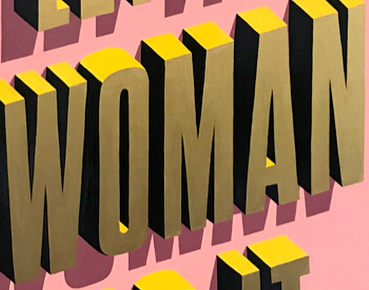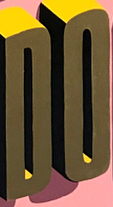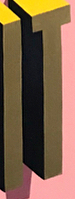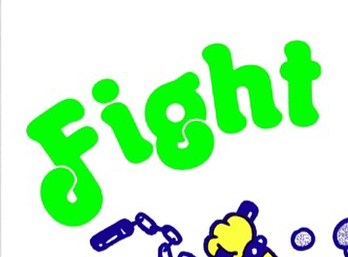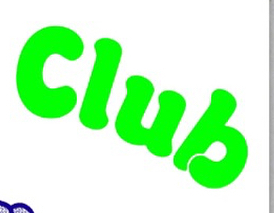Read the text content from these images in order, separated by a semicolon. WOMAN; DO; IT; Fight; Club 